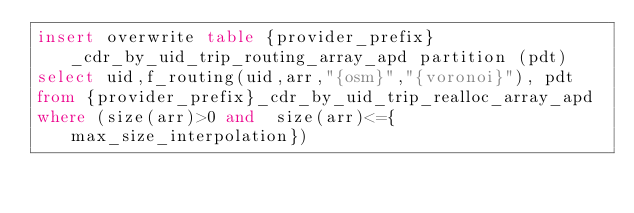Convert code to text. <code><loc_0><loc_0><loc_500><loc_500><_SQL_>insert overwrite table {provider_prefix}_cdr_by_uid_trip_routing_array_apd partition (pdt)
select uid,f_routing(uid,arr,"{osm}","{voronoi}"), pdt
from {provider_prefix}_cdr_by_uid_trip_realloc_array_apd
where (size(arr)>0 and  size(arr)<={max_size_interpolation})
</code> 